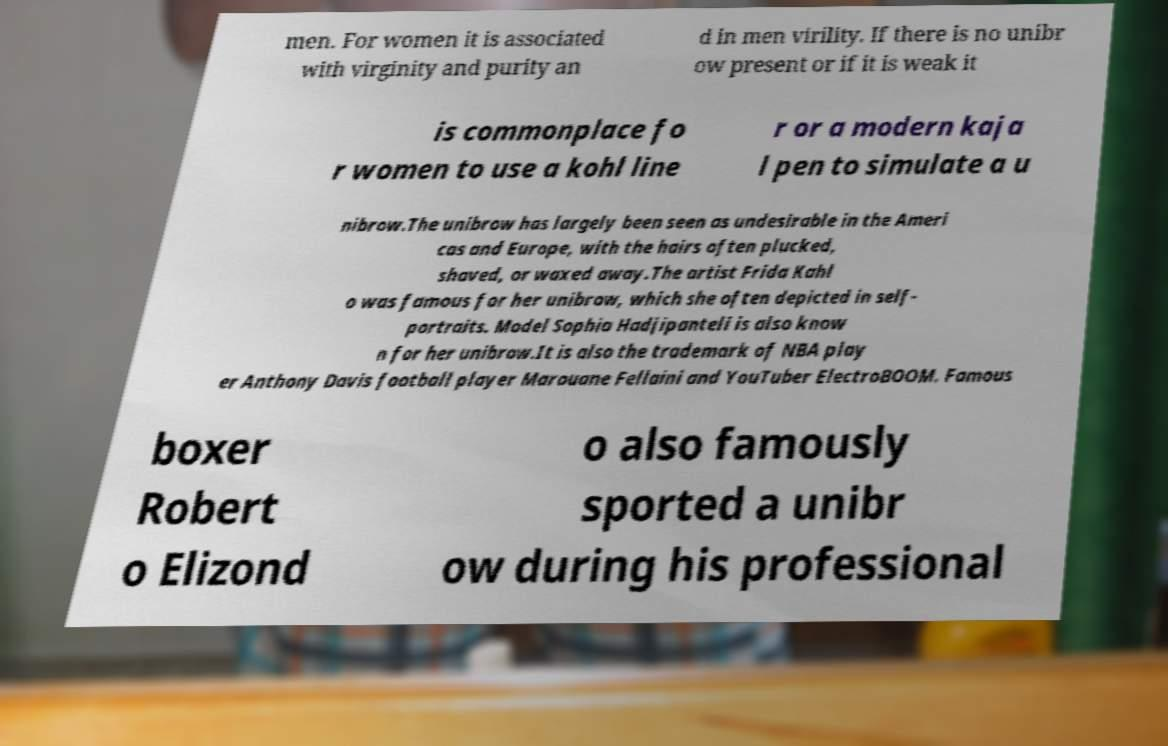Can you accurately transcribe the text from the provided image for me? men. For women it is associated with virginity and purity an d in men virility. If there is no unibr ow present or if it is weak it is commonplace fo r women to use a kohl line r or a modern kaja l pen to simulate a u nibrow.The unibrow has largely been seen as undesirable in the Ameri cas and Europe, with the hairs often plucked, shaved, or waxed away.The artist Frida Kahl o was famous for her unibrow, which she often depicted in self- portraits. Model Sophia Hadjipanteli is also know n for her unibrow.It is also the trademark of NBA play er Anthony Davis football player Marouane Fellaini and YouTuber ElectroBOOM. Famous boxer Robert o Elizond o also famously sported a unibr ow during his professional 